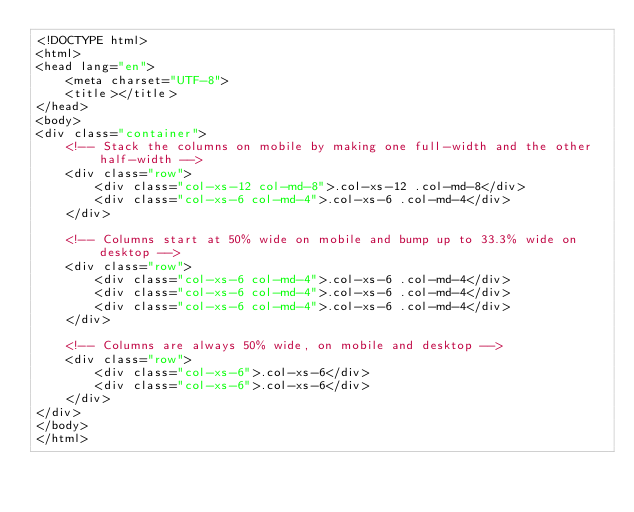<code> <loc_0><loc_0><loc_500><loc_500><_HTML_><!DOCTYPE html>
<html>
<head lang="en">
    <meta charset="UTF-8">
    <title></title>
</head>
<body>
<div class="container">
    <!-- Stack the columns on mobile by making one full-width and the other half-width -->
    <div class="row">
        <div class="col-xs-12 col-md-8">.col-xs-12 .col-md-8</div>
        <div class="col-xs-6 col-md-4">.col-xs-6 .col-md-4</div>
    </div>

    <!-- Columns start at 50% wide on mobile and bump up to 33.3% wide on desktop -->
    <div class="row">
        <div class="col-xs-6 col-md-4">.col-xs-6 .col-md-4</div>
        <div class="col-xs-6 col-md-4">.col-xs-6 .col-md-4</div>
        <div class="col-xs-6 col-md-4">.col-xs-6 .col-md-4</div>
    </div>

    <!-- Columns are always 50% wide, on mobile and desktop -->
    <div class="row">
        <div class="col-xs-6">.col-xs-6</div>
        <div class="col-xs-6">.col-xs-6</div>
    </div>
</div>
</body>
</html></code> 